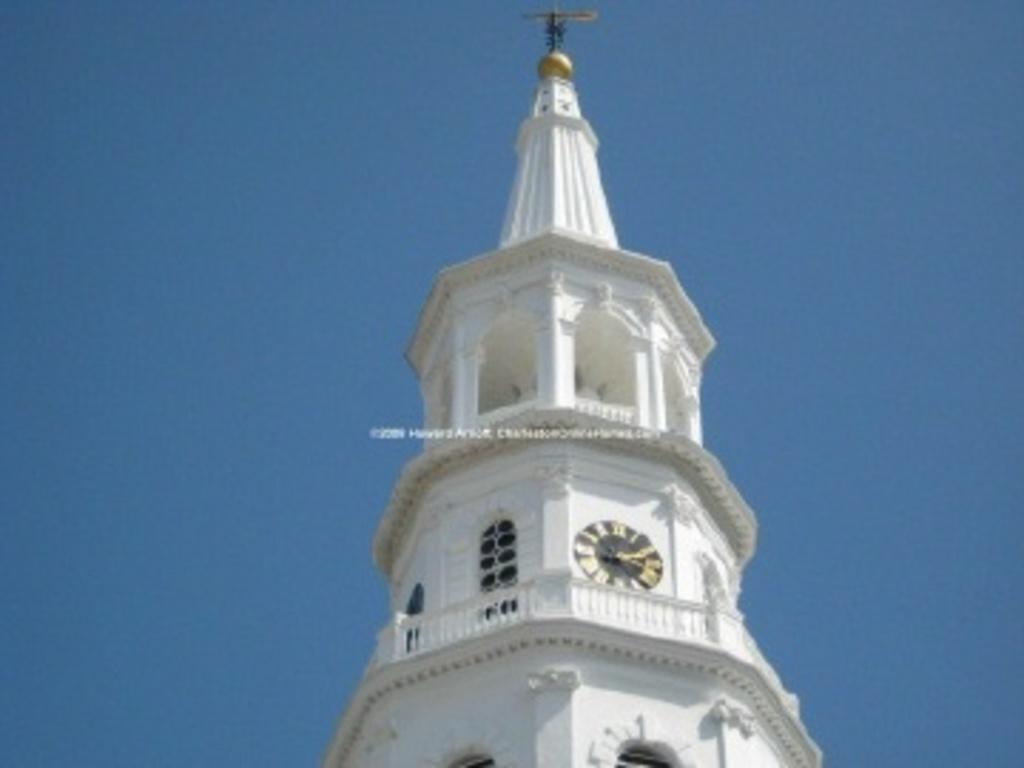What is the main structure in the picture? There is a clock tower in the picture. Is there anything attached to the clock tower? Yes, a block is attached to the clock tower. What is the condition of the sky in the image? The sky is clear in the image. Can you tell me how many beasts are playing with the block in the image? There are no beasts present in the image, and therefore no such activity can be observed. Who is the friend that the clock tower is talking to in the image? Clock towers do not have the ability to talk or have friends, so this scenario is not present in the image. 